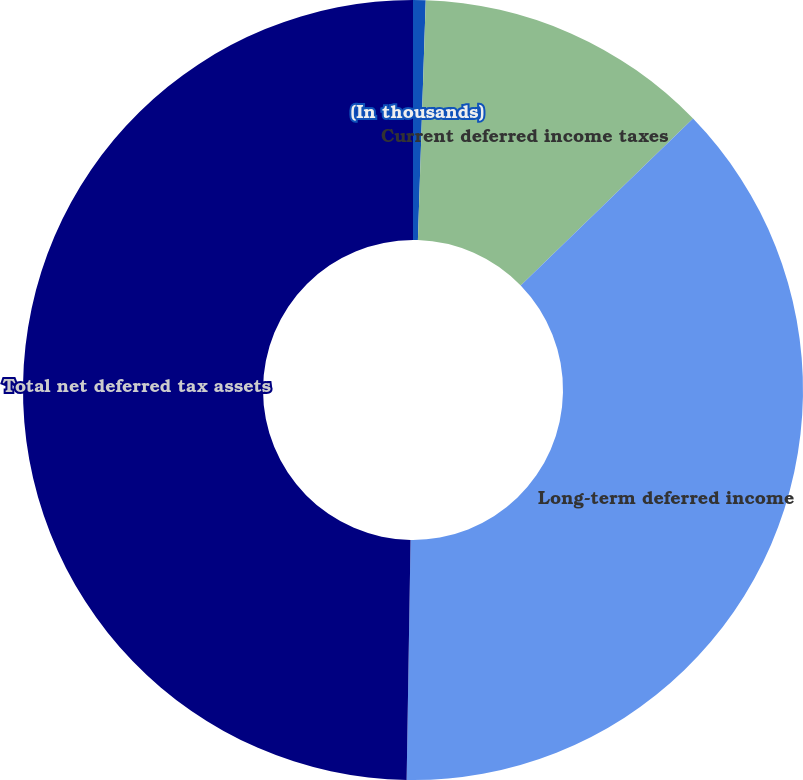<chart> <loc_0><loc_0><loc_500><loc_500><pie_chart><fcel>(In thousands)<fcel>Current deferred income taxes<fcel>Long-term deferred income<fcel>Total net deferred tax assets<nl><fcel>0.52%<fcel>12.23%<fcel>37.51%<fcel>49.74%<nl></chart> 